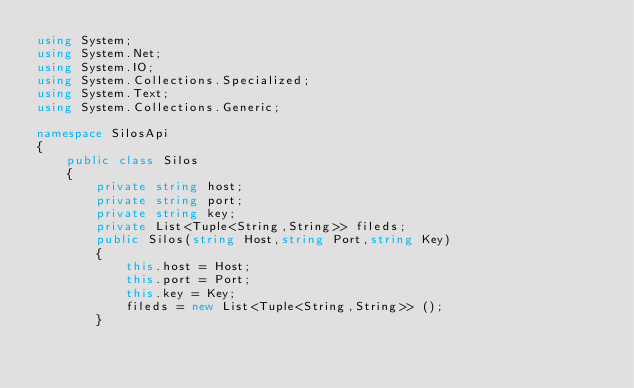<code> <loc_0><loc_0><loc_500><loc_500><_C#_>using System;
using System.Net;
using System.IO;
using System.Collections.Specialized;
using System.Text;
using System.Collections.Generic;

namespace SilosApi
{
	public class Silos
	{
		private string host;
		private string port;
		private string key;
		private List<Tuple<String,String>> fileds;
		public Silos(string Host,string Port,string Key)
		{
			this.host = Host;
			this.port = Port;
			this.key = Key;
			fileds = new List<Tuple<String,String>> ();
		}</code> 